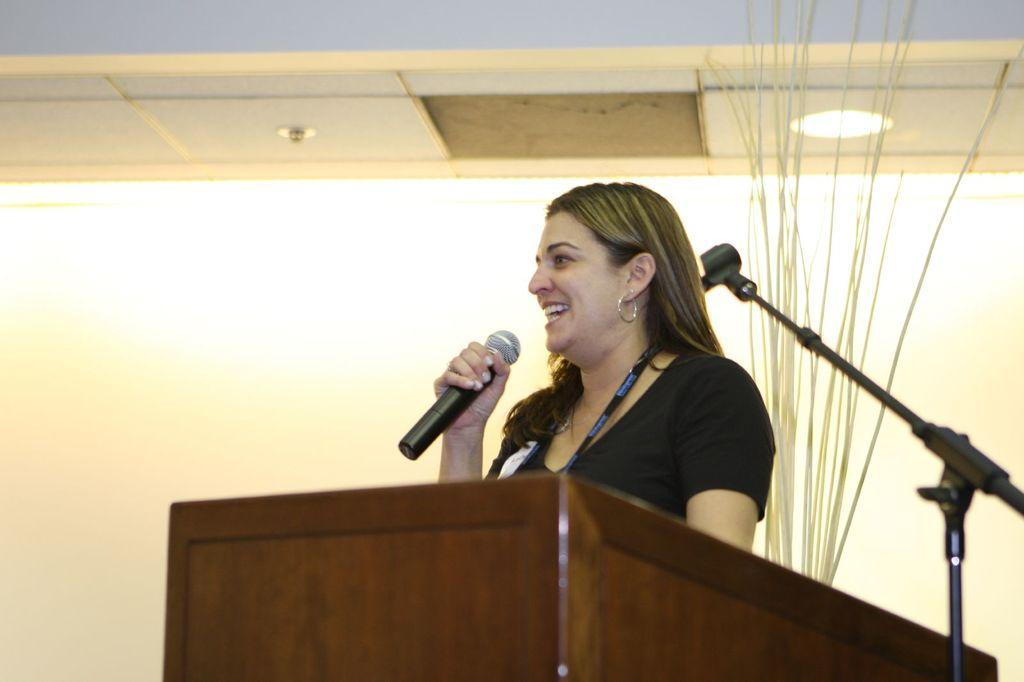Who is the main subject in the image? There is a woman in the image. What is the woman doing in the image? The woman is standing and holding a mic. What object can be seen near the woman in the image? There is a podium in the image. What are the names of the pets that are present in the image? There are no pets visible in the image. How many police officers can be seen in the image? There are no police officers present in the image. 